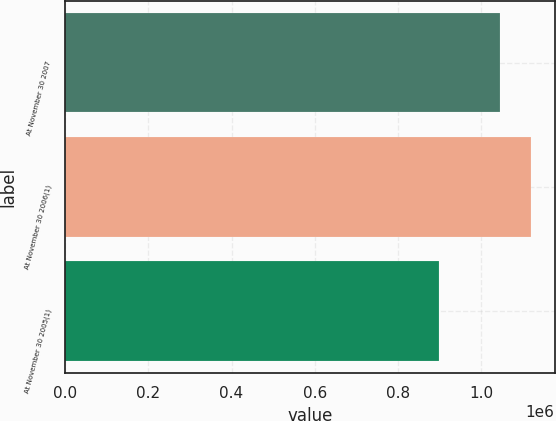Convert chart to OTSL. <chart><loc_0><loc_0><loc_500><loc_500><bar_chart><fcel>At November 30 2007<fcel>At November 30 2006(1)<fcel>At November 30 2005(1)<nl><fcel>1.04541e+06<fcel>1.12119e+06<fcel>898835<nl></chart> 